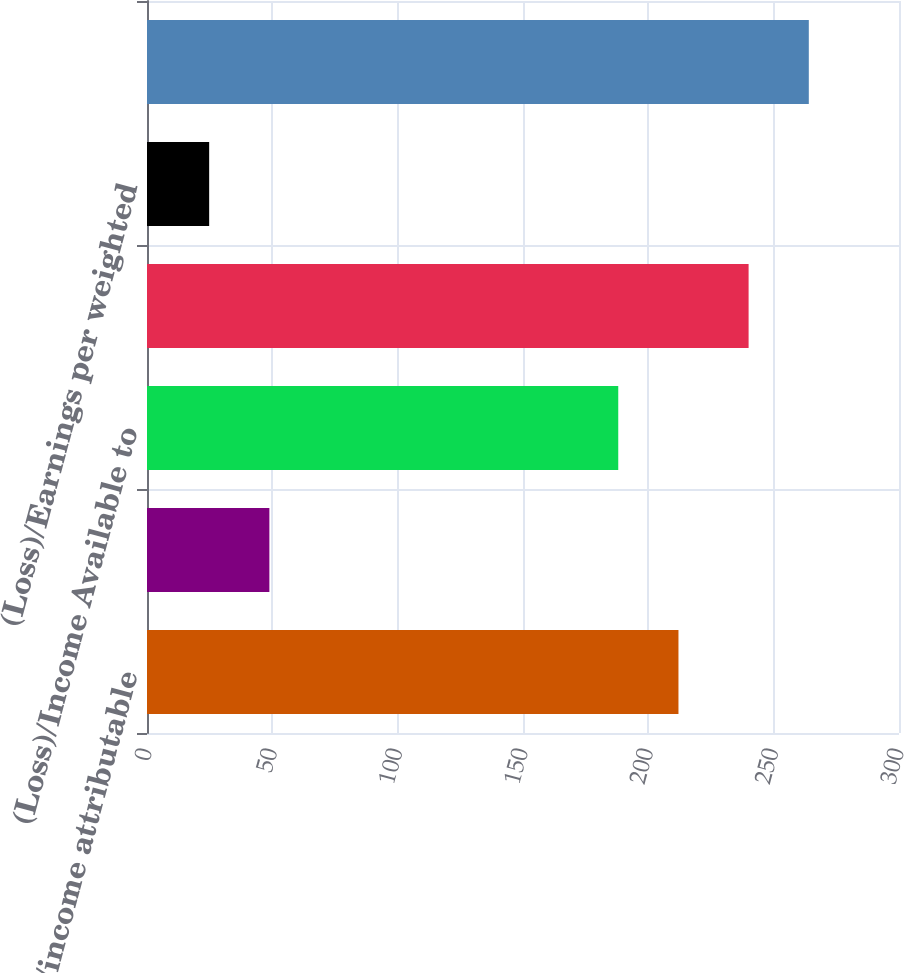Convert chart to OTSL. <chart><loc_0><loc_0><loc_500><loc_500><bar_chart><fcel>Net (loss)/income attributable<fcel>Dividends for preferred shares<fcel>(Loss)/Income Available to<fcel>Weighted average number of<fcel>(Loss)/Earnings per weighted<fcel>Total dilutive shares<nl><fcel>212.02<fcel>48.82<fcel>188<fcel>240<fcel>24.8<fcel>264.02<nl></chart> 